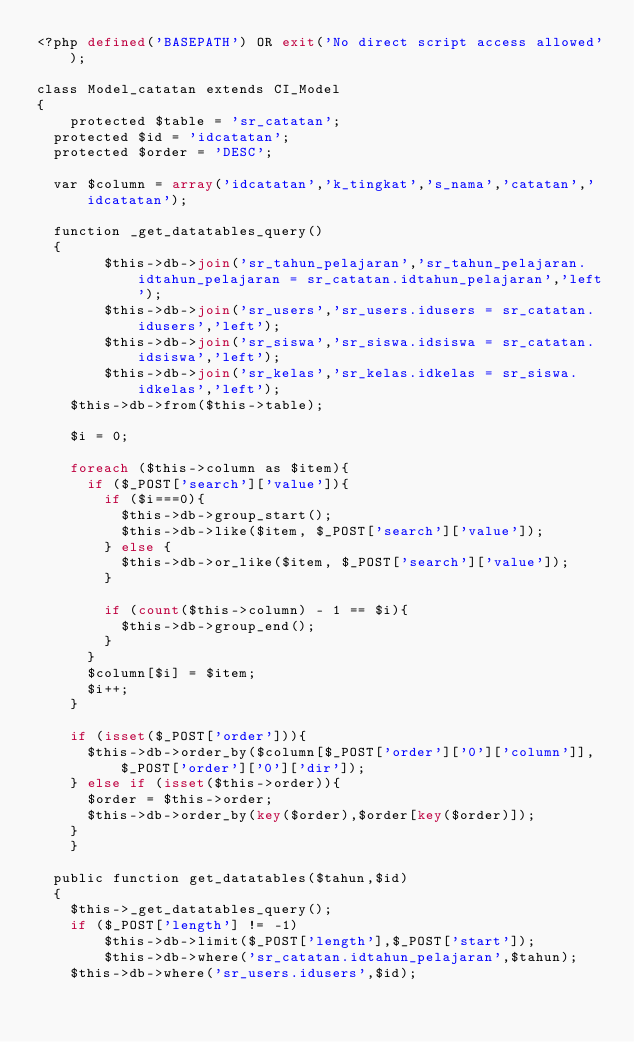<code> <loc_0><loc_0><loc_500><loc_500><_PHP_><?php defined('BASEPATH') OR exit('No direct script access allowed');

class Model_catatan extends CI_Model
{
    protected $table = 'sr_catatan';
	protected $id = 'idcatatan';
	protected $order = 'DESC';

	var $column = array('idcatatan','k_tingkat','s_nama','catatan','idcatatan');

	function _get_datatables_query()
	{
        $this->db->join('sr_tahun_pelajaran','sr_tahun_pelajaran.idtahun_pelajaran = sr_catatan.idtahun_pelajaran','left');
        $this->db->join('sr_users','sr_users.idusers = sr_catatan.idusers','left');
        $this->db->join('sr_siswa','sr_siswa.idsiswa = sr_catatan.idsiswa','left');
        $this->db->join('sr_kelas','sr_kelas.idkelas = sr_siswa.idkelas','left');
		$this->db->from($this->table);

		$i = 0;

		foreach ($this->column as $item){
			if ($_POST['search']['value']){
				if ($i===0){
					$this->db->group_start();
					$this->db->like($item, $_POST['search']['value']);
				} else {
					$this->db->or_like($item, $_POST['search']['value']);
				}

				if (count($this->column) - 1 == $i){
					$this->db->group_end();
				}
			}
			$column[$i] = $item;
			$i++;
		}

		if (isset($_POST['order'])){
			$this->db->order_by($column[$_POST['order']['0']['column']], $_POST['order']['0']['dir']);
		} else if (isset($this->order)){
			$order = $this->order;
			$this->db->order_by(key($order),$order[key($order)]);
		}
    }

	public function get_datatables($tahun,$id)
	{
		$this->_get_datatables_query();
		if ($_POST['length'] != -1)
        $this->db->limit($_POST['length'],$_POST['start']);
        $this->db->where('sr_catatan.idtahun_pelajaran',$tahun);
		$this->db->where('sr_users.idusers',$id);</code> 